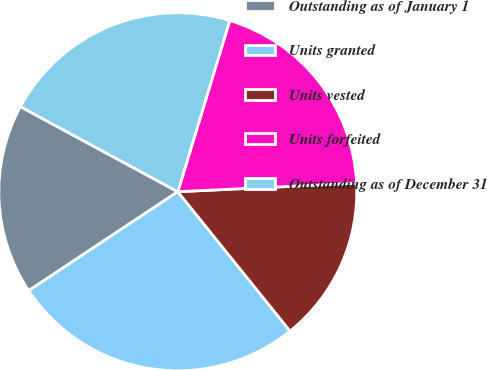<chart> <loc_0><loc_0><loc_500><loc_500><pie_chart><fcel>Outstanding as of January 1<fcel>Units granted<fcel>Units vested<fcel>Units forfeited<fcel>Outstanding as of December 31<nl><fcel>17.21%<fcel>26.47%<fcel>14.97%<fcel>19.55%<fcel>21.8%<nl></chart> 